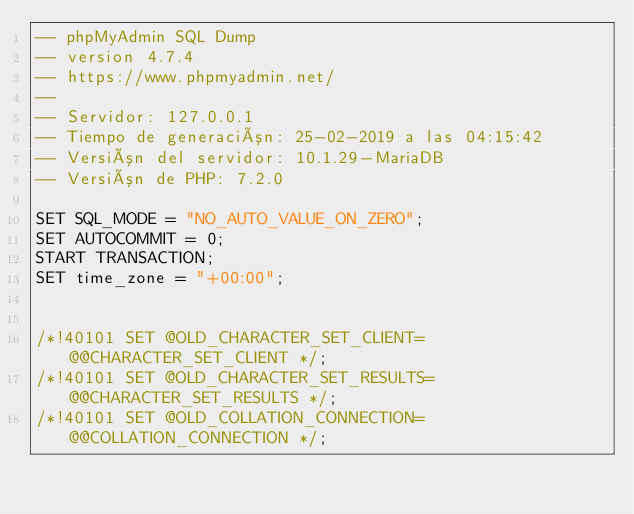Convert code to text. <code><loc_0><loc_0><loc_500><loc_500><_SQL_>-- phpMyAdmin SQL Dump
-- version 4.7.4
-- https://www.phpmyadmin.net/
--
-- Servidor: 127.0.0.1
-- Tiempo de generación: 25-02-2019 a las 04:15:42
-- Versión del servidor: 10.1.29-MariaDB
-- Versión de PHP: 7.2.0

SET SQL_MODE = "NO_AUTO_VALUE_ON_ZERO";
SET AUTOCOMMIT = 0;
START TRANSACTION;
SET time_zone = "+00:00";


/*!40101 SET @OLD_CHARACTER_SET_CLIENT=@@CHARACTER_SET_CLIENT */;
/*!40101 SET @OLD_CHARACTER_SET_RESULTS=@@CHARACTER_SET_RESULTS */;
/*!40101 SET @OLD_COLLATION_CONNECTION=@@COLLATION_CONNECTION */;</code> 